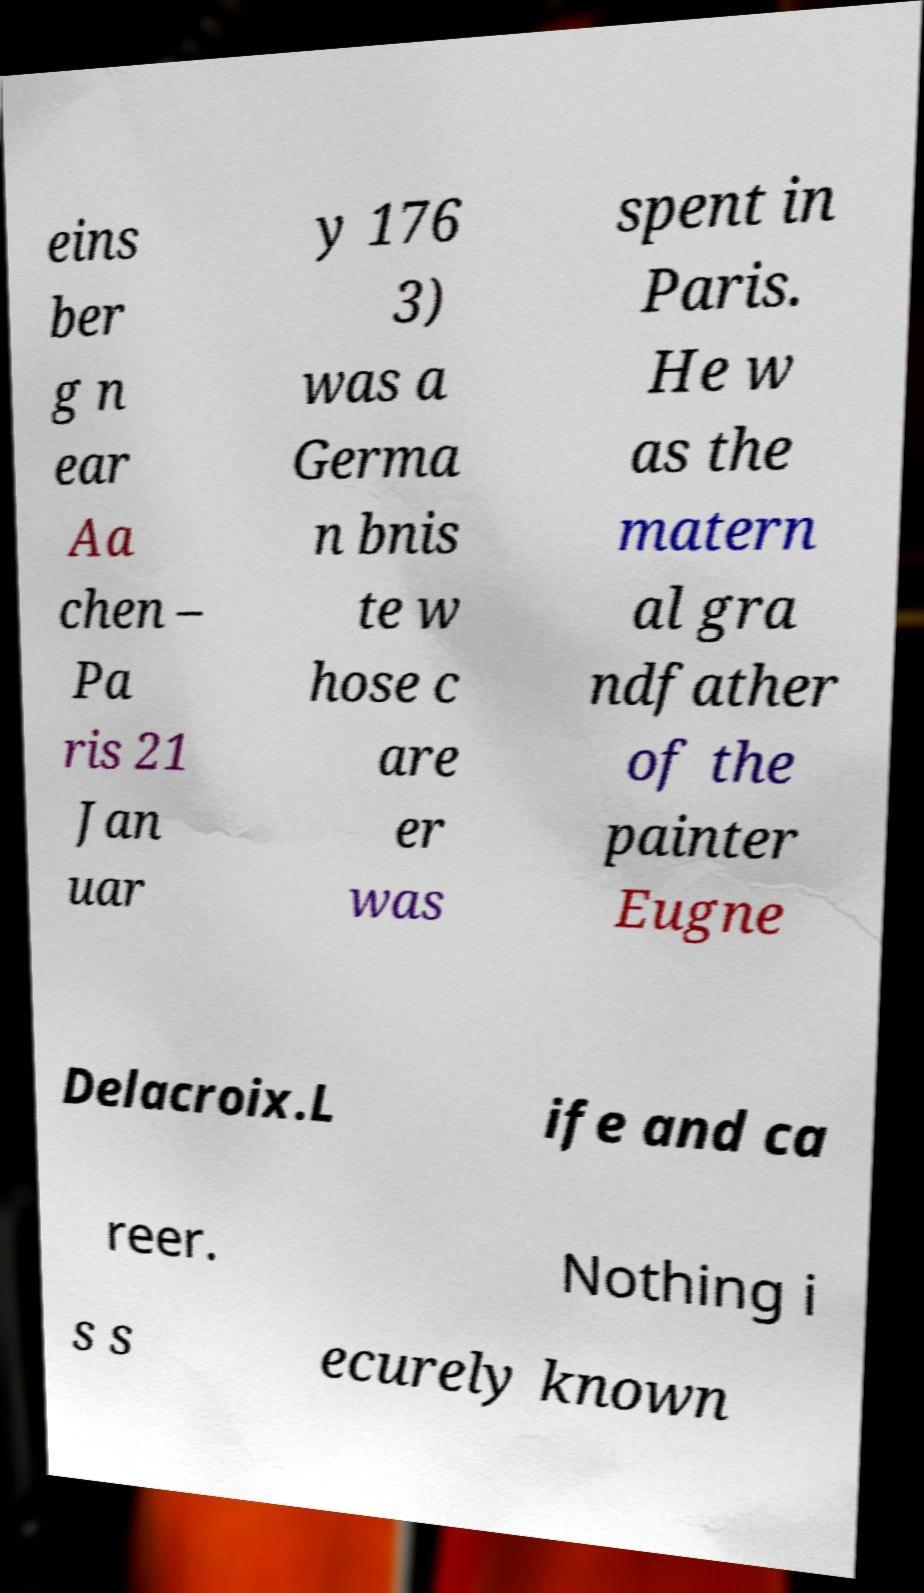I need the written content from this picture converted into text. Can you do that? eins ber g n ear Aa chen – Pa ris 21 Jan uar y 176 3) was a Germa n bnis te w hose c are er was spent in Paris. He w as the matern al gra ndfather of the painter Eugne Delacroix.L ife and ca reer. Nothing i s s ecurely known 